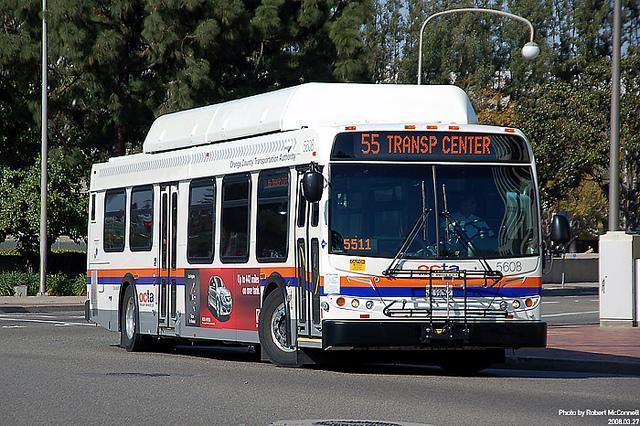How many windows are on one side of the bus?
Give a very brief answer. 5. 